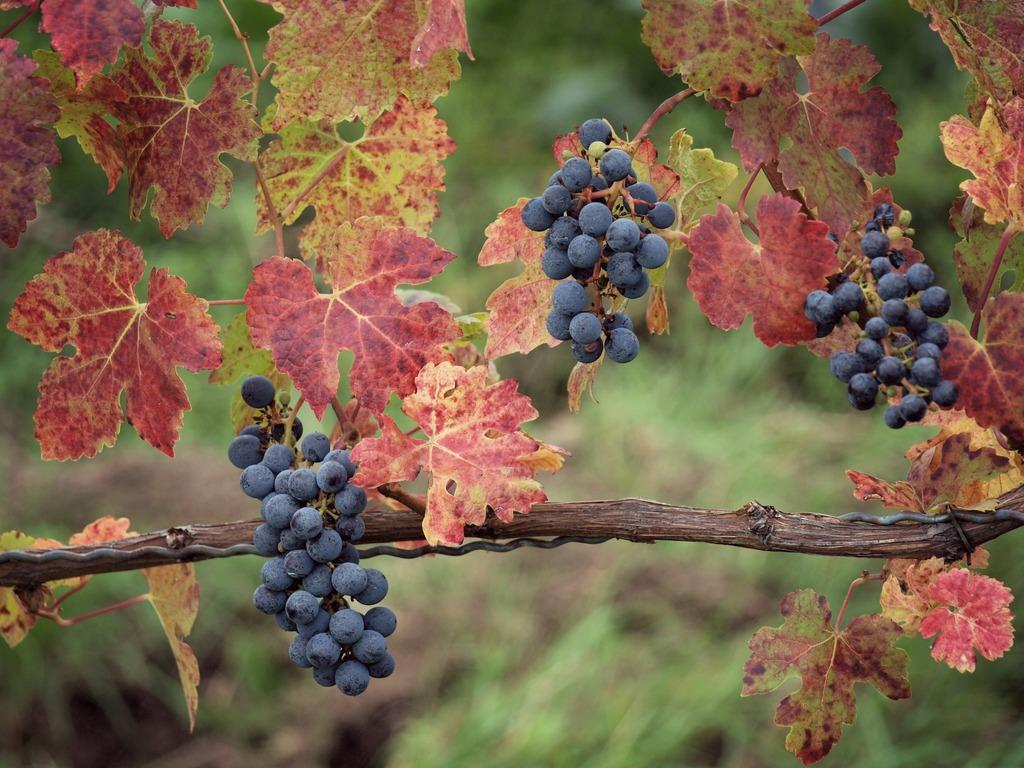What type of fruit can be seen in the image? There are berries in the image. What else is present in the image besides the berries? There are leaves and plants in the image. How would you describe the background of the image? The background of the image is blurred. What type of powder can be seen covering the leaves in the image? There is no powder present in the image; the leaves are not covered in any substance. 